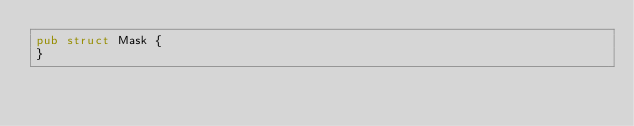Convert code to text. <code><loc_0><loc_0><loc_500><loc_500><_Rust_>pub struct Mask {
}
</code> 